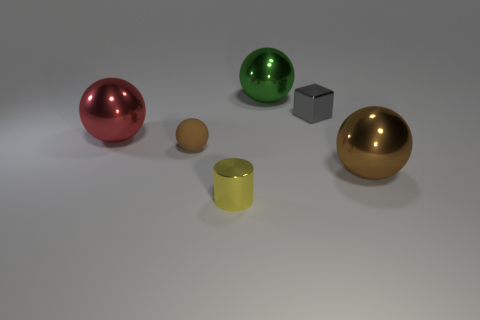Subtract all big red balls. How many balls are left? 3 Subtract all red cylinders. How many brown balls are left? 2 Add 4 brown balls. How many objects exist? 10 Subtract all green spheres. How many spheres are left? 3 Subtract all spheres. How many objects are left? 2 Subtract 3 spheres. How many spheres are left? 1 Subtract 1 red balls. How many objects are left? 5 Subtract all red balls. Subtract all green blocks. How many balls are left? 3 Subtract all large gray metal things. Subtract all big green metal objects. How many objects are left? 5 Add 2 large brown things. How many large brown things are left? 3 